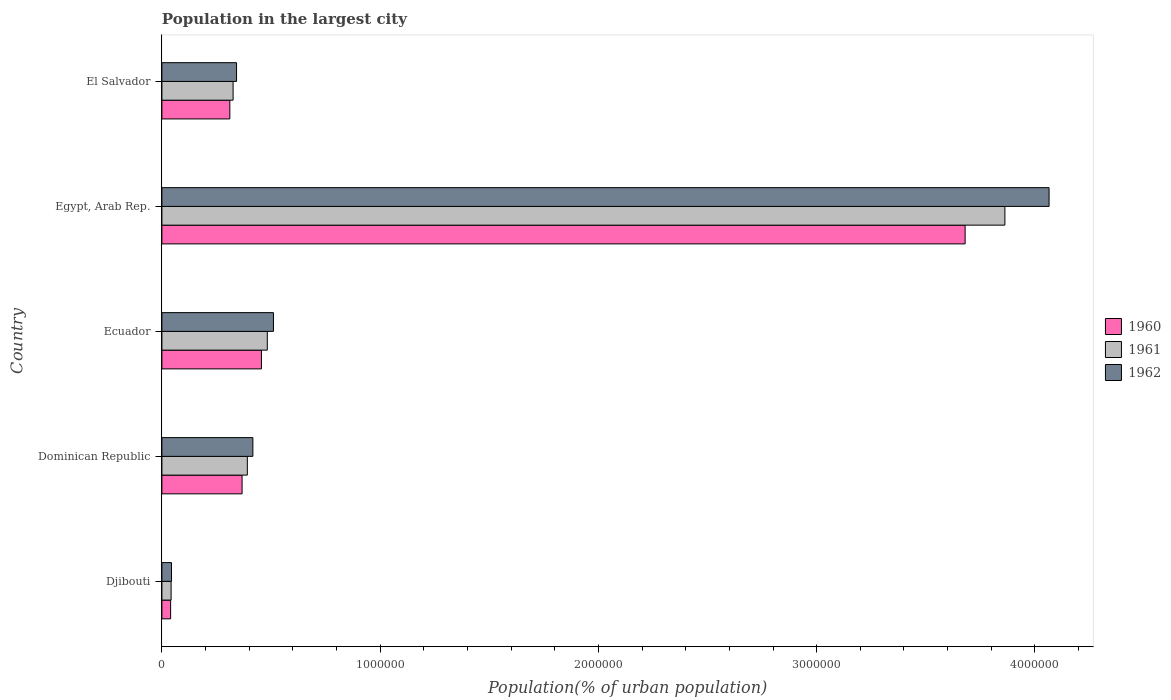How many different coloured bars are there?
Offer a very short reply. 3. Are the number of bars on each tick of the Y-axis equal?
Offer a terse response. Yes. How many bars are there on the 2nd tick from the bottom?
Your answer should be compact. 3. What is the label of the 5th group of bars from the top?
Provide a succinct answer. Djibouti. In how many cases, is the number of bars for a given country not equal to the number of legend labels?
Offer a terse response. 0. What is the population in the largest city in 1962 in Ecuador?
Offer a very short reply. 5.11e+05. Across all countries, what is the maximum population in the largest city in 1961?
Give a very brief answer. 3.86e+06. Across all countries, what is the minimum population in the largest city in 1960?
Offer a terse response. 4.00e+04. In which country was the population in the largest city in 1961 maximum?
Keep it short and to the point. Egypt, Arab Rep. In which country was the population in the largest city in 1960 minimum?
Give a very brief answer. Djibouti. What is the total population in the largest city in 1961 in the graph?
Your answer should be very brief. 5.11e+06. What is the difference between the population in the largest city in 1962 in Dominican Republic and that in Egypt, Arab Rep.?
Offer a terse response. -3.65e+06. What is the difference between the population in the largest city in 1962 in Egypt, Arab Rep. and the population in the largest city in 1961 in Ecuador?
Offer a very short reply. 3.58e+06. What is the average population in the largest city in 1962 per country?
Provide a short and direct response. 1.08e+06. What is the difference between the population in the largest city in 1961 and population in the largest city in 1960 in Djibouti?
Your answer should be very brief. 2241. What is the ratio of the population in the largest city in 1961 in Djibouti to that in Dominican Republic?
Ensure brevity in your answer.  0.11. Is the population in the largest city in 1961 in Egypt, Arab Rep. less than that in El Salvador?
Ensure brevity in your answer.  No. What is the difference between the highest and the second highest population in the largest city in 1961?
Keep it short and to the point. 3.38e+06. What is the difference between the highest and the lowest population in the largest city in 1960?
Keep it short and to the point. 3.64e+06. In how many countries, is the population in the largest city in 1961 greater than the average population in the largest city in 1961 taken over all countries?
Ensure brevity in your answer.  1. Is the sum of the population in the largest city in 1960 in Djibouti and Dominican Republic greater than the maximum population in the largest city in 1961 across all countries?
Offer a terse response. No. Is it the case that in every country, the sum of the population in the largest city in 1962 and population in the largest city in 1961 is greater than the population in the largest city in 1960?
Give a very brief answer. Yes. Are all the bars in the graph horizontal?
Offer a terse response. Yes. Does the graph contain grids?
Provide a short and direct response. No. Where does the legend appear in the graph?
Make the answer very short. Center right. How many legend labels are there?
Your answer should be compact. 3. How are the legend labels stacked?
Give a very brief answer. Vertical. What is the title of the graph?
Provide a short and direct response. Population in the largest city. What is the label or title of the X-axis?
Your response must be concise. Population(% of urban population). What is the label or title of the Y-axis?
Your response must be concise. Country. What is the Population(% of urban population) in 1960 in Djibouti?
Your answer should be compact. 4.00e+04. What is the Population(% of urban population) in 1961 in Djibouti?
Provide a short and direct response. 4.22e+04. What is the Population(% of urban population) in 1962 in Djibouti?
Offer a terse response. 4.40e+04. What is the Population(% of urban population) in 1960 in Dominican Republic?
Offer a terse response. 3.67e+05. What is the Population(% of urban population) in 1961 in Dominican Republic?
Your answer should be compact. 3.91e+05. What is the Population(% of urban population) of 1962 in Dominican Republic?
Provide a short and direct response. 4.17e+05. What is the Population(% of urban population) in 1960 in Ecuador?
Your response must be concise. 4.56e+05. What is the Population(% of urban population) in 1961 in Ecuador?
Your answer should be compact. 4.83e+05. What is the Population(% of urban population) in 1962 in Ecuador?
Your response must be concise. 5.11e+05. What is the Population(% of urban population) of 1960 in Egypt, Arab Rep.?
Your response must be concise. 3.68e+06. What is the Population(% of urban population) of 1961 in Egypt, Arab Rep.?
Offer a terse response. 3.86e+06. What is the Population(% of urban population) in 1962 in Egypt, Arab Rep.?
Your answer should be very brief. 4.06e+06. What is the Population(% of urban population) in 1960 in El Salvador?
Offer a very short reply. 3.11e+05. What is the Population(% of urban population) of 1961 in El Salvador?
Your response must be concise. 3.26e+05. What is the Population(% of urban population) of 1962 in El Salvador?
Offer a terse response. 3.42e+05. Across all countries, what is the maximum Population(% of urban population) of 1960?
Give a very brief answer. 3.68e+06. Across all countries, what is the maximum Population(% of urban population) in 1961?
Your response must be concise. 3.86e+06. Across all countries, what is the maximum Population(% of urban population) in 1962?
Offer a very short reply. 4.06e+06. Across all countries, what is the minimum Population(% of urban population) of 1960?
Your answer should be very brief. 4.00e+04. Across all countries, what is the minimum Population(% of urban population) in 1961?
Provide a succinct answer. 4.22e+04. Across all countries, what is the minimum Population(% of urban population) in 1962?
Ensure brevity in your answer.  4.40e+04. What is the total Population(% of urban population) of 1960 in the graph?
Provide a short and direct response. 4.85e+06. What is the total Population(% of urban population) of 1961 in the graph?
Provide a short and direct response. 5.11e+06. What is the total Population(% of urban population) in 1962 in the graph?
Provide a short and direct response. 5.38e+06. What is the difference between the Population(% of urban population) in 1960 in Djibouti and that in Dominican Republic?
Offer a terse response. -3.27e+05. What is the difference between the Population(% of urban population) of 1961 in Djibouti and that in Dominican Republic?
Keep it short and to the point. -3.49e+05. What is the difference between the Population(% of urban population) in 1962 in Djibouti and that in Dominican Republic?
Offer a very short reply. -3.73e+05. What is the difference between the Population(% of urban population) of 1960 in Djibouti and that in Ecuador?
Offer a very short reply. -4.16e+05. What is the difference between the Population(% of urban population) in 1961 in Djibouti and that in Ecuador?
Your answer should be very brief. -4.41e+05. What is the difference between the Population(% of urban population) of 1962 in Djibouti and that in Ecuador?
Give a very brief answer. -4.67e+05. What is the difference between the Population(% of urban population) of 1960 in Djibouti and that in Egypt, Arab Rep.?
Your answer should be compact. -3.64e+06. What is the difference between the Population(% of urban population) of 1961 in Djibouti and that in Egypt, Arab Rep.?
Offer a very short reply. -3.82e+06. What is the difference between the Population(% of urban population) in 1962 in Djibouti and that in Egypt, Arab Rep.?
Your answer should be compact. -4.02e+06. What is the difference between the Population(% of urban population) in 1960 in Djibouti and that in El Salvador?
Provide a succinct answer. -2.71e+05. What is the difference between the Population(% of urban population) in 1961 in Djibouti and that in El Salvador?
Ensure brevity in your answer.  -2.84e+05. What is the difference between the Population(% of urban population) in 1962 in Djibouti and that in El Salvador?
Make the answer very short. -2.98e+05. What is the difference between the Population(% of urban population) in 1960 in Dominican Republic and that in Ecuador?
Your response must be concise. -8.89e+04. What is the difference between the Population(% of urban population) of 1961 in Dominican Republic and that in Ecuador?
Give a very brief answer. -9.14e+04. What is the difference between the Population(% of urban population) of 1962 in Dominican Republic and that in Ecuador?
Keep it short and to the point. -9.43e+04. What is the difference between the Population(% of urban population) in 1960 in Dominican Republic and that in Egypt, Arab Rep.?
Ensure brevity in your answer.  -3.31e+06. What is the difference between the Population(% of urban population) of 1961 in Dominican Republic and that in Egypt, Arab Rep.?
Your response must be concise. -3.47e+06. What is the difference between the Population(% of urban population) in 1962 in Dominican Republic and that in Egypt, Arab Rep.?
Offer a terse response. -3.65e+06. What is the difference between the Population(% of urban population) of 1960 in Dominican Republic and that in El Salvador?
Offer a terse response. 5.61e+04. What is the difference between the Population(% of urban population) in 1961 in Dominican Republic and that in El Salvador?
Provide a succinct answer. 6.52e+04. What is the difference between the Population(% of urban population) of 1962 in Dominican Republic and that in El Salvador?
Provide a short and direct response. 7.48e+04. What is the difference between the Population(% of urban population) in 1960 in Ecuador and that in Egypt, Arab Rep.?
Offer a very short reply. -3.22e+06. What is the difference between the Population(% of urban population) in 1961 in Ecuador and that in Egypt, Arab Rep.?
Make the answer very short. -3.38e+06. What is the difference between the Population(% of urban population) of 1962 in Ecuador and that in Egypt, Arab Rep.?
Your answer should be compact. -3.55e+06. What is the difference between the Population(% of urban population) of 1960 in Ecuador and that in El Salvador?
Offer a terse response. 1.45e+05. What is the difference between the Population(% of urban population) in 1961 in Ecuador and that in El Salvador?
Make the answer very short. 1.57e+05. What is the difference between the Population(% of urban population) of 1962 in Ecuador and that in El Salvador?
Provide a short and direct response. 1.69e+05. What is the difference between the Population(% of urban population) of 1960 in Egypt, Arab Rep. and that in El Salvador?
Your response must be concise. 3.37e+06. What is the difference between the Population(% of urban population) of 1961 in Egypt, Arab Rep. and that in El Salvador?
Your answer should be compact. 3.54e+06. What is the difference between the Population(% of urban population) in 1962 in Egypt, Arab Rep. and that in El Salvador?
Offer a very short reply. 3.72e+06. What is the difference between the Population(% of urban population) of 1960 in Djibouti and the Population(% of urban population) of 1961 in Dominican Republic?
Your answer should be very brief. -3.51e+05. What is the difference between the Population(% of urban population) of 1960 in Djibouti and the Population(% of urban population) of 1962 in Dominican Republic?
Your response must be concise. -3.77e+05. What is the difference between the Population(% of urban population) of 1961 in Djibouti and the Population(% of urban population) of 1962 in Dominican Republic?
Offer a very short reply. -3.75e+05. What is the difference between the Population(% of urban population) of 1960 in Djibouti and the Population(% of urban population) of 1961 in Ecuador?
Give a very brief answer. -4.43e+05. What is the difference between the Population(% of urban population) in 1960 in Djibouti and the Population(% of urban population) in 1962 in Ecuador?
Provide a short and direct response. -4.71e+05. What is the difference between the Population(% of urban population) of 1961 in Djibouti and the Population(% of urban population) of 1962 in Ecuador?
Ensure brevity in your answer.  -4.69e+05. What is the difference between the Population(% of urban population) in 1960 in Djibouti and the Population(% of urban population) in 1961 in Egypt, Arab Rep.?
Your answer should be very brief. -3.82e+06. What is the difference between the Population(% of urban population) of 1960 in Djibouti and the Population(% of urban population) of 1962 in Egypt, Arab Rep.?
Offer a very short reply. -4.02e+06. What is the difference between the Population(% of urban population) of 1961 in Djibouti and the Population(% of urban population) of 1962 in Egypt, Arab Rep.?
Your answer should be compact. -4.02e+06. What is the difference between the Population(% of urban population) in 1960 in Djibouti and the Population(% of urban population) in 1961 in El Salvador?
Your answer should be very brief. -2.86e+05. What is the difference between the Population(% of urban population) of 1960 in Djibouti and the Population(% of urban population) of 1962 in El Salvador?
Offer a very short reply. -3.02e+05. What is the difference between the Population(% of urban population) of 1961 in Djibouti and the Population(% of urban population) of 1962 in El Salvador?
Make the answer very short. -3.00e+05. What is the difference between the Population(% of urban population) in 1960 in Dominican Republic and the Population(% of urban population) in 1961 in Ecuador?
Offer a terse response. -1.16e+05. What is the difference between the Population(% of urban population) in 1960 in Dominican Republic and the Population(% of urban population) in 1962 in Ecuador?
Ensure brevity in your answer.  -1.44e+05. What is the difference between the Population(% of urban population) of 1961 in Dominican Republic and the Population(% of urban population) of 1962 in Ecuador?
Your answer should be very brief. -1.20e+05. What is the difference between the Population(% of urban population) of 1960 in Dominican Republic and the Population(% of urban population) of 1961 in Egypt, Arab Rep.?
Provide a succinct answer. -3.50e+06. What is the difference between the Population(% of urban population) of 1960 in Dominican Republic and the Population(% of urban population) of 1962 in Egypt, Arab Rep.?
Ensure brevity in your answer.  -3.70e+06. What is the difference between the Population(% of urban population) of 1961 in Dominican Republic and the Population(% of urban population) of 1962 in Egypt, Arab Rep.?
Your answer should be compact. -3.67e+06. What is the difference between the Population(% of urban population) in 1960 in Dominican Republic and the Population(% of urban population) in 1961 in El Salvador?
Provide a short and direct response. 4.11e+04. What is the difference between the Population(% of urban population) of 1960 in Dominican Republic and the Population(% of urban population) of 1962 in El Salvador?
Your answer should be compact. 2.53e+04. What is the difference between the Population(% of urban population) of 1961 in Dominican Republic and the Population(% of urban population) of 1962 in El Salvador?
Make the answer very short. 4.94e+04. What is the difference between the Population(% of urban population) in 1960 in Ecuador and the Population(% of urban population) in 1961 in Egypt, Arab Rep.?
Offer a very short reply. -3.41e+06. What is the difference between the Population(% of urban population) of 1960 in Ecuador and the Population(% of urban population) of 1962 in Egypt, Arab Rep.?
Give a very brief answer. -3.61e+06. What is the difference between the Population(% of urban population) in 1961 in Ecuador and the Population(% of urban population) in 1962 in Egypt, Arab Rep.?
Keep it short and to the point. -3.58e+06. What is the difference between the Population(% of urban population) in 1960 in Ecuador and the Population(% of urban population) in 1961 in El Salvador?
Ensure brevity in your answer.  1.30e+05. What is the difference between the Population(% of urban population) of 1960 in Ecuador and the Population(% of urban population) of 1962 in El Salvador?
Your response must be concise. 1.14e+05. What is the difference between the Population(% of urban population) in 1961 in Ecuador and the Population(% of urban population) in 1962 in El Salvador?
Your answer should be very brief. 1.41e+05. What is the difference between the Population(% of urban population) of 1960 in Egypt, Arab Rep. and the Population(% of urban population) of 1961 in El Salvador?
Your answer should be very brief. 3.35e+06. What is the difference between the Population(% of urban population) in 1960 in Egypt, Arab Rep. and the Population(% of urban population) in 1962 in El Salvador?
Ensure brevity in your answer.  3.34e+06. What is the difference between the Population(% of urban population) in 1961 in Egypt, Arab Rep. and the Population(% of urban population) in 1962 in El Salvador?
Provide a short and direct response. 3.52e+06. What is the average Population(% of urban population) of 1960 per country?
Keep it short and to the point. 9.71e+05. What is the average Population(% of urban population) in 1961 per country?
Your answer should be very brief. 1.02e+06. What is the average Population(% of urban population) of 1962 per country?
Provide a succinct answer. 1.08e+06. What is the difference between the Population(% of urban population) of 1960 and Population(% of urban population) of 1961 in Djibouti?
Offer a terse response. -2241. What is the difference between the Population(% of urban population) in 1960 and Population(% of urban population) in 1962 in Djibouti?
Offer a terse response. -4084. What is the difference between the Population(% of urban population) of 1961 and Population(% of urban population) of 1962 in Djibouti?
Offer a very short reply. -1843. What is the difference between the Population(% of urban population) of 1960 and Population(% of urban population) of 1961 in Dominican Republic?
Your answer should be compact. -2.41e+04. What is the difference between the Population(% of urban population) in 1960 and Population(% of urban population) in 1962 in Dominican Republic?
Provide a short and direct response. -4.95e+04. What is the difference between the Population(% of urban population) of 1961 and Population(% of urban population) of 1962 in Dominican Republic?
Your response must be concise. -2.54e+04. What is the difference between the Population(% of urban population) of 1960 and Population(% of urban population) of 1961 in Ecuador?
Your answer should be compact. -2.66e+04. What is the difference between the Population(% of urban population) of 1960 and Population(% of urban population) of 1962 in Ecuador?
Give a very brief answer. -5.49e+04. What is the difference between the Population(% of urban population) of 1961 and Population(% of urban population) of 1962 in Ecuador?
Your answer should be compact. -2.82e+04. What is the difference between the Population(% of urban population) in 1960 and Population(% of urban population) in 1961 in Egypt, Arab Rep.?
Your answer should be very brief. -1.82e+05. What is the difference between the Population(% of urban population) in 1960 and Population(% of urban population) in 1962 in Egypt, Arab Rep.?
Provide a succinct answer. -3.85e+05. What is the difference between the Population(% of urban population) in 1961 and Population(% of urban population) in 1962 in Egypt, Arab Rep.?
Your response must be concise. -2.02e+05. What is the difference between the Population(% of urban population) in 1960 and Population(% of urban population) in 1961 in El Salvador?
Provide a short and direct response. -1.50e+04. What is the difference between the Population(% of urban population) of 1960 and Population(% of urban population) of 1962 in El Salvador?
Offer a terse response. -3.08e+04. What is the difference between the Population(% of urban population) of 1961 and Population(% of urban population) of 1962 in El Salvador?
Provide a short and direct response. -1.58e+04. What is the ratio of the Population(% of urban population) of 1960 in Djibouti to that in Dominican Republic?
Give a very brief answer. 0.11. What is the ratio of the Population(% of urban population) of 1961 in Djibouti to that in Dominican Republic?
Provide a short and direct response. 0.11. What is the ratio of the Population(% of urban population) of 1962 in Djibouti to that in Dominican Republic?
Keep it short and to the point. 0.11. What is the ratio of the Population(% of urban population) of 1960 in Djibouti to that in Ecuador?
Keep it short and to the point. 0.09. What is the ratio of the Population(% of urban population) of 1961 in Djibouti to that in Ecuador?
Provide a short and direct response. 0.09. What is the ratio of the Population(% of urban population) of 1962 in Djibouti to that in Ecuador?
Your answer should be compact. 0.09. What is the ratio of the Population(% of urban population) of 1960 in Djibouti to that in Egypt, Arab Rep.?
Ensure brevity in your answer.  0.01. What is the ratio of the Population(% of urban population) in 1961 in Djibouti to that in Egypt, Arab Rep.?
Offer a very short reply. 0.01. What is the ratio of the Population(% of urban population) of 1962 in Djibouti to that in Egypt, Arab Rep.?
Give a very brief answer. 0.01. What is the ratio of the Population(% of urban population) in 1960 in Djibouti to that in El Salvador?
Make the answer very short. 0.13. What is the ratio of the Population(% of urban population) of 1961 in Djibouti to that in El Salvador?
Your answer should be compact. 0.13. What is the ratio of the Population(% of urban population) in 1962 in Djibouti to that in El Salvador?
Keep it short and to the point. 0.13. What is the ratio of the Population(% of urban population) of 1960 in Dominican Republic to that in Ecuador?
Provide a succinct answer. 0.81. What is the ratio of the Population(% of urban population) of 1961 in Dominican Republic to that in Ecuador?
Your answer should be very brief. 0.81. What is the ratio of the Population(% of urban population) in 1962 in Dominican Republic to that in Ecuador?
Ensure brevity in your answer.  0.82. What is the ratio of the Population(% of urban population) of 1960 in Dominican Republic to that in Egypt, Arab Rep.?
Provide a succinct answer. 0.1. What is the ratio of the Population(% of urban population) in 1961 in Dominican Republic to that in Egypt, Arab Rep.?
Provide a succinct answer. 0.1. What is the ratio of the Population(% of urban population) of 1962 in Dominican Republic to that in Egypt, Arab Rep.?
Offer a very short reply. 0.1. What is the ratio of the Population(% of urban population) in 1960 in Dominican Republic to that in El Salvador?
Your answer should be compact. 1.18. What is the ratio of the Population(% of urban population) in 1961 in Dominican Republic to that in El Salvador?
Your answer should be compact. 1.2. What is the ratio of the Population(% of urban population) in 1962 in Dominican Republic to that in El Salvador?
Your response must be concise. 1.22. What is the ratio of the Population(% of urban population) in 1960 in Ecuador to that in Egypt, Arab Rep.?
Your response must be concise. 0.12. What is the ratio of the Population(% of urban population) in 1962 in Ecuador to that in Egypt, Arab Rep.?
Offer a terse response. 0.13. What is the ratio of the Population(% of urban population) of 1960 in Ecuador to that in El Salvador?
Your answer should be compact. 1.47. What is the ratio of the Population(% of urban population) of 1961 in Ecuador to that in El Salvador?
Keep it short and to the point. 1.48. What is the ratio of the Population(% of urban population) of 1962 in Ecuador to that in El Salvador?
Make the answer very short. 1.49. What is the ratio of the Population(% of urban population) of 1960 in Egypt, Arab Rep. to that in El Salvador?
Your answer should be compact. 11.83. What is the ratio of the Population(% of urban population) of 1961 in Egypt, Arab Rep. to that in El Salvador?
Provide a short and direct response. 11.84. What is the ratio of the Population(% of urban population) of 1962 in Egypt, Arab Rep. to that in El Salvador?
Your answer should be very brief. 11.88. What is the difference between the highest and the second highest Population(% of urban population) in 1960?
Provide a succinct answer. 3.22e+06. What is the difference between the highest and the second highest Population(% of urban population) of 1961?
Provide a succinct answer. 3.38e+06. What is the difference between the highest and the second highest Population(% of urban population) in 1962?
Give a very brief answer. 3.55e+06. What is the difference between the highest and the lowest Population(% of urban population) in 1960?
Make the answer very short. 3.64e+06. What is the difference between the highest and the lowest Population(% of urban population) in 1961?
Your answer should be compact. 3.82e+06. What is the difference between the highest and the lowest Population(% of urban population) of 1962?
Provide a short and direct response. 4.02e+06. 